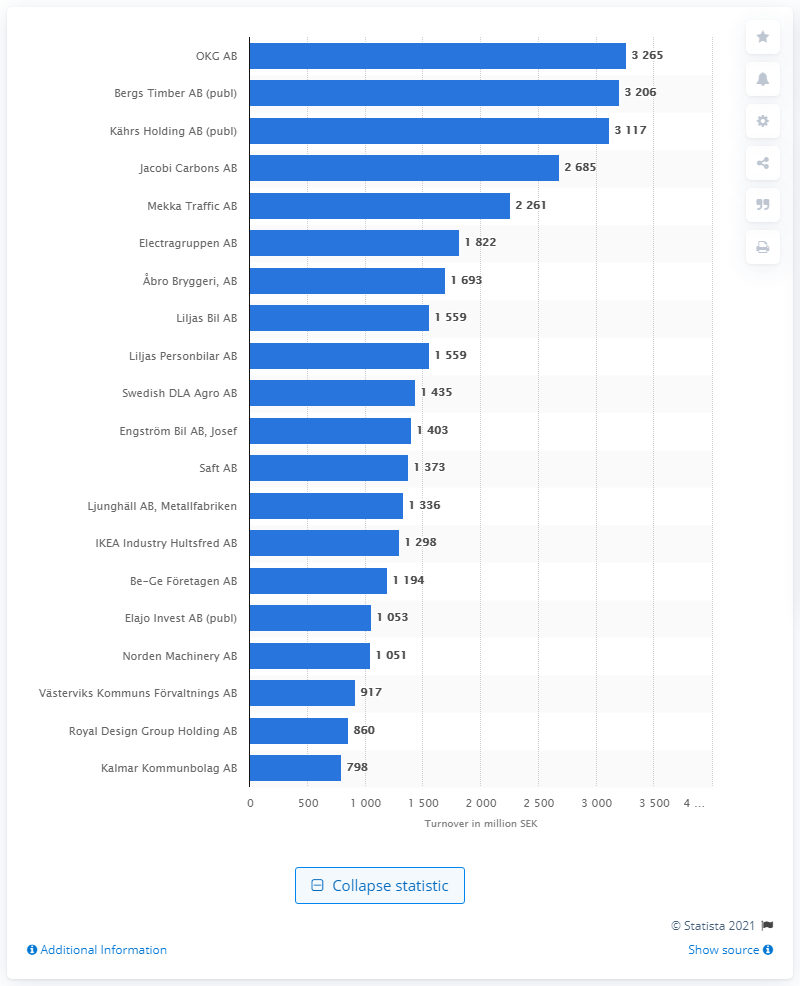Give some essential details in this illustration. OKG AB was the leading company in Kalmar as of February 2021. 